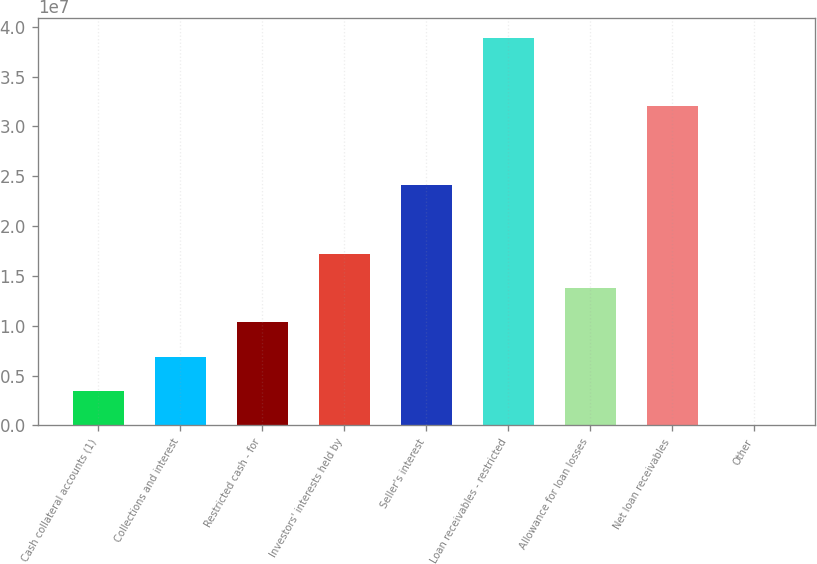Convert chart. <chart><loc_0><loc_0><loc_500><loc_500><bar_chart><fcel>Cash collateral accounts (1)<fcel>Collections and interest<fcel>Restricted cash - for<fcel>Investors' interests held by<fcel>Seller's interest<fcel>Loan receivables - restricted<fcel>Allowance for loan losses<fcel>Net loan receivables<fcel>Other<nl><fcel>3.46697e+06<fcel>6.90986e+06<fcel>1.03528e+07<fcel>1.72385e+07<fcel>2.41243e+07<fcel>3.89074e+07<fcel>1.37956e+07<fcel>3.20216e+07<fcel>24083<nl></chart> 